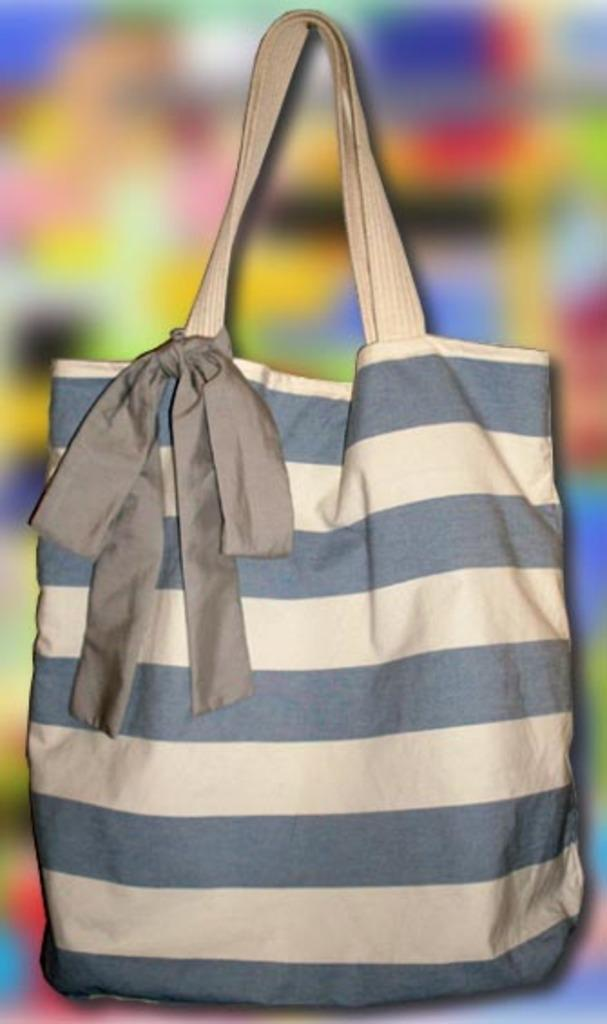What object is present in the image that can be used for carrying items? There is a bag in the image that can be used for carrying items. What colors are visible on the bag in the image? The bag has a combination of grey and white colors. How are the colors arranged on the bag? The bag has horizontal lines. What other object can be seen in the image besides the bag? There is a ribbon in the image. What type of ground can be seen in the image? There is no ground visible in the image; it only features a bag and a ribbon. Can you tell me how many pickles are in the bag? There is no information about pickles in the image; it only shows a bag with horizontal lines and a ribbon. 